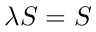<formula> <loc_0><loc_0><loc_500><loc_500>\lambda S = S</formula> 